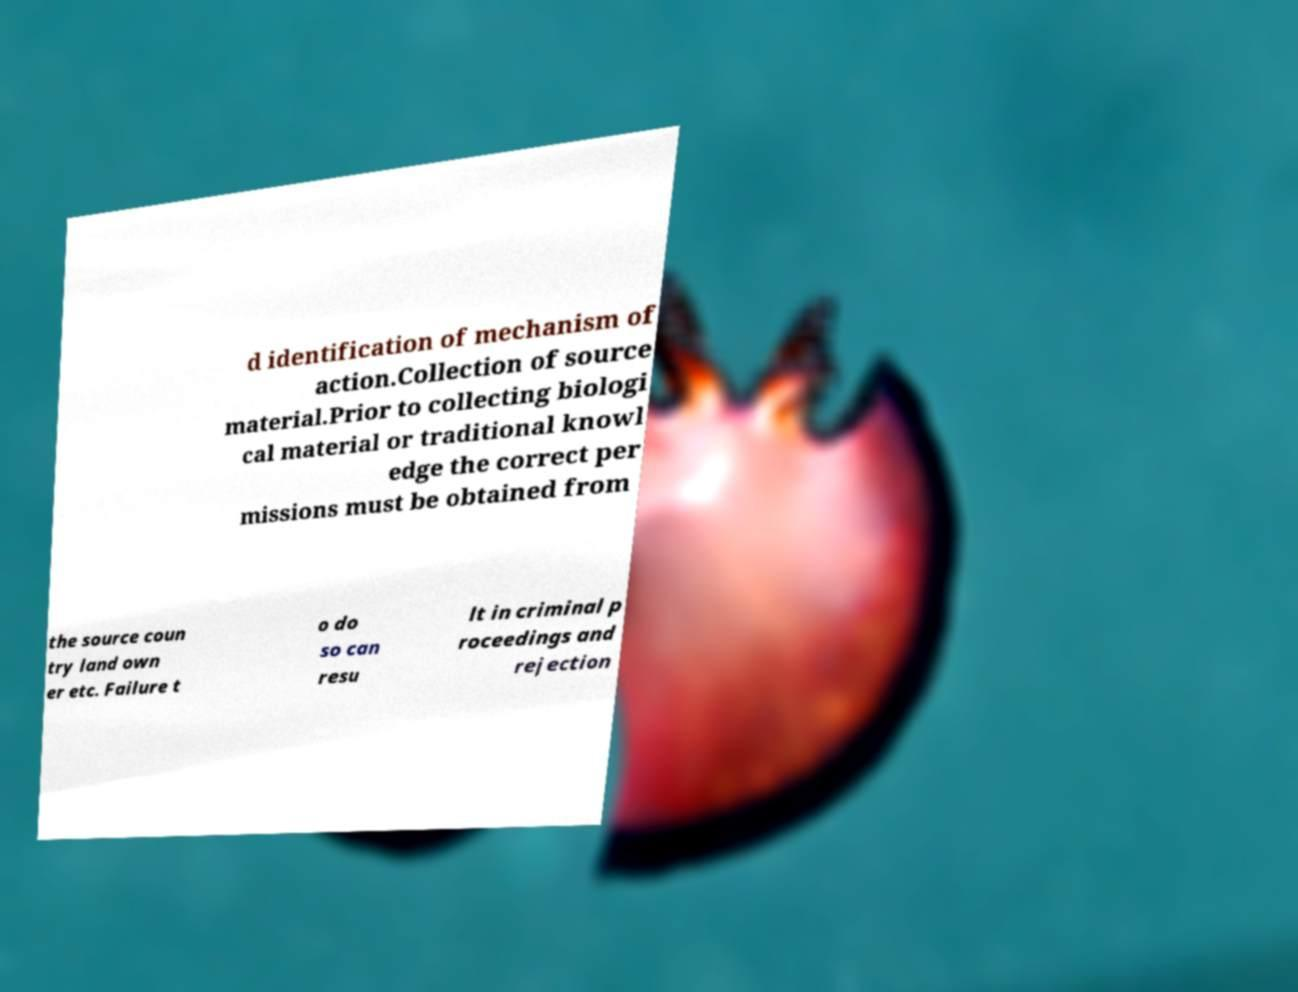Could you assist in decoding the text presented in this image and type it out clearly? d identification of mechanism of action.Collection of source material.Prior to collecting biologi cal material or traditional knowl edge the correct per missions must be obtained from the source coun try land own er etc. Failure t o do so can resu lt in criminal p roceedings and rejection 